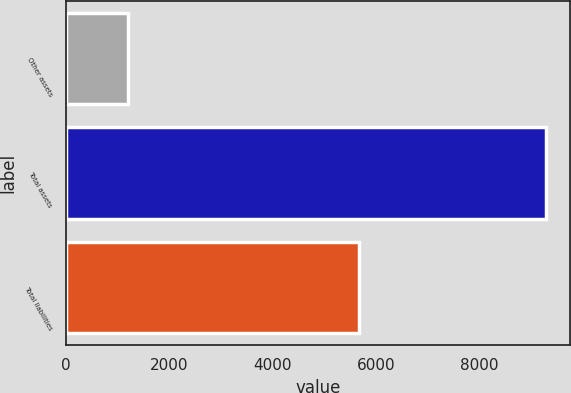Convert chart. <chart><loc_0><loc_0><loc_500><loc_500><bar_chart><fcel>Other assets<fcel>Total assets<fcel>Total liabilities<nl><fcel>1205<fcel>9294<fcel>5665<nl></chart> 